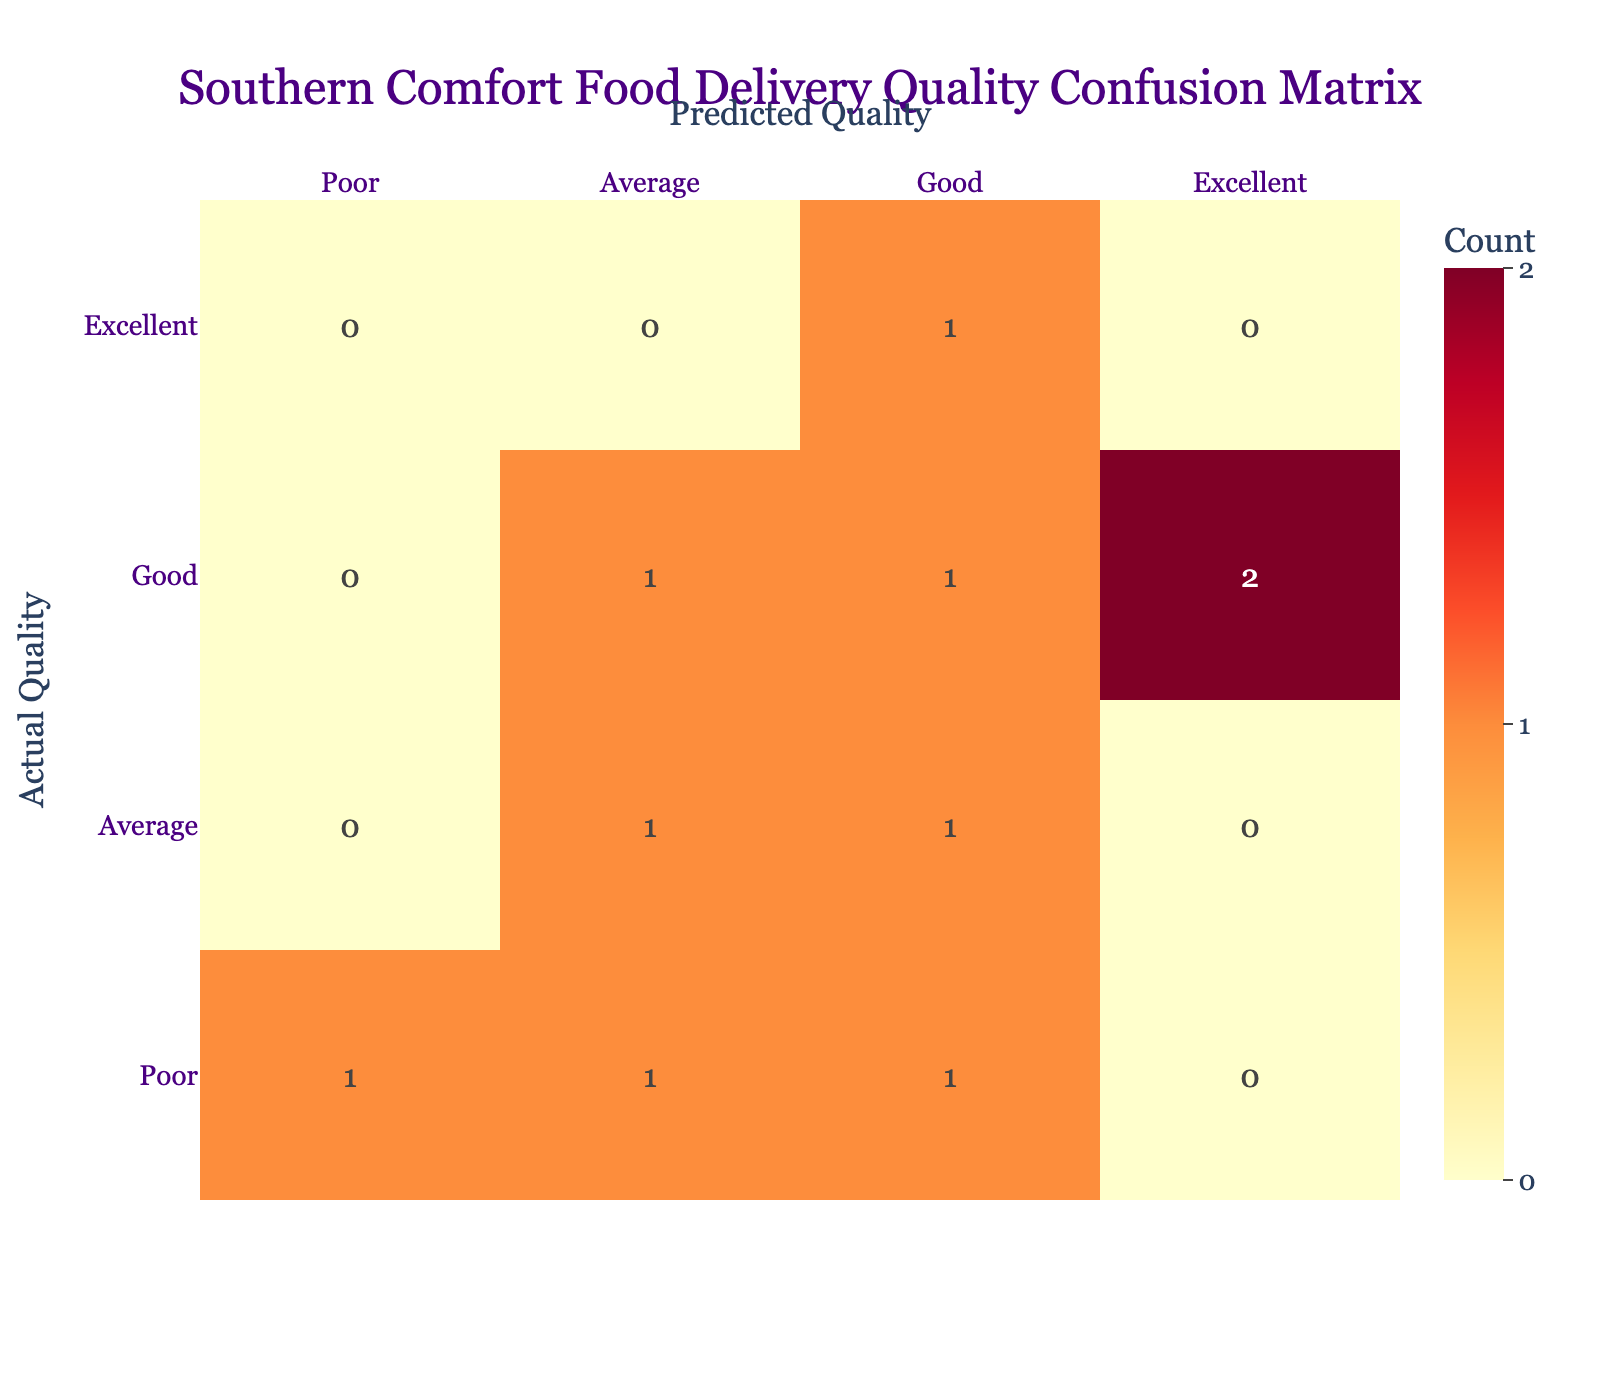What is the predicted quality for Daisy's Southern Comfort? According to the table, Daisy's Southern Comfort has a predicted delivery quality of "Average".
Answer: Average How many restaurants were predicted to have "Excellent" delivery quality? The table shows that only one restaurant, Gus's World Famous Fried Chicken, was predicted to have "Excellent" delivery quality.
Answer: 1 Did any restaurant have a predicted "Poor" delivery quality that was actually "Good"? Yes, Daisy's Southern Comfort had a predicted quality of "Average" but the actual quality was "Good".
Answer: No What's the difference between the number of restaurants predicted to have "Good" quality compared to those with "Poor" quality? There are 3 restaurants predicted to have "Good" quality (Hattie B's, Creole Kitchen, and Martin's Bar-B-Que) while there is 1 restaurant with "Poor" quality (Lady & Sons). The difference is 3 - 1 = 2.
Answer: 2 Are there any restaurants where predicted and actual quality were both "Average"? Yes, Biscuit Love had both predicted and actual quality classified as "Average".
Answer: Yes What percentage of restaurants were predicted to have an actual quality of "Good"? There are 4 restaurants that had an actual quality of "Good" out of a total of 10 restaurants. Thus, the percentage is (4/10) * 100 = 40%.
Answer: 40% Which restaurant had the highest discrepancy between predicted and actual quality? Gus's World Famous Fried Chicken had a predicted quality of "Good", but the actual quality was "Excellent", indicating the highest positive discrepancy.
Answer: Gus's World Famous Fried Chicken What is the total number of restaurants rated "Average" in actual quality? Looking at the table, there are 3 restaurants (Biscuit Love, Creole Kitchen, and Daisy's Southern Comfort) rated "Average" in actual quality.
Answer: 3 Was there any restaurant that was overestimated in its delivery quality? Yes, the restaurant Martin's Bar-B-Que was predicted to have "Good", but the actual quality was "Poor", hence it was overestimated.
Answer: Yes 